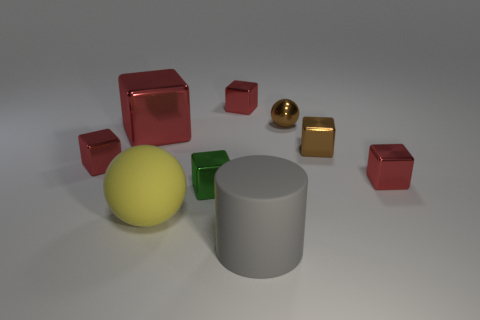What is the shape of the metallic thing that is both on the right side of the large gray rubber cylinder and on the left side of the brown shiny block?
Offer a terse response. Sphere. The thing that is on the left side of the gray matte thing and behind the large red metallic cube is what color?
Keep it short and to the point. Red. Is the number of green cubes that are on the left side of the big shiny block greater than the number of large things?
Your answer should be compact. No. Do the big red thing and the big gray matte thing have the same shape?
Offer a terse response. No. What is the size of the green shiny cube?
Provide a short and direct response. Small. Are there more large objects that are on the left side of the yellow thing than small red cubes that are behind the small metallic ball?
Your response must be concise. No. Are there any small brown objects behind the large red shiny thing?
Your answer should be compact. Yes. Is there another gray matte thing of the same size as the gray thing?
Give a very brief answer. No. What color is the other big block that is the same material as the brown cube?
Offer a terse response. Red. What is the big cylinder made of?
Your answer should be very brief. Rubber. 